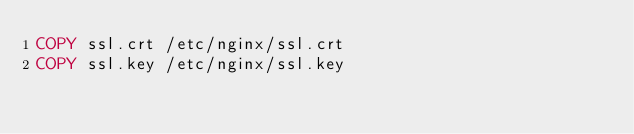Convert code to text. <code><loc_0><loc_0><loc_500><loc_500><_Dockerfile_>COPY ssl.crt /etc/nginx/ssl.crt
COPY ssl.key /etc/nginx/ssl.key</code> 